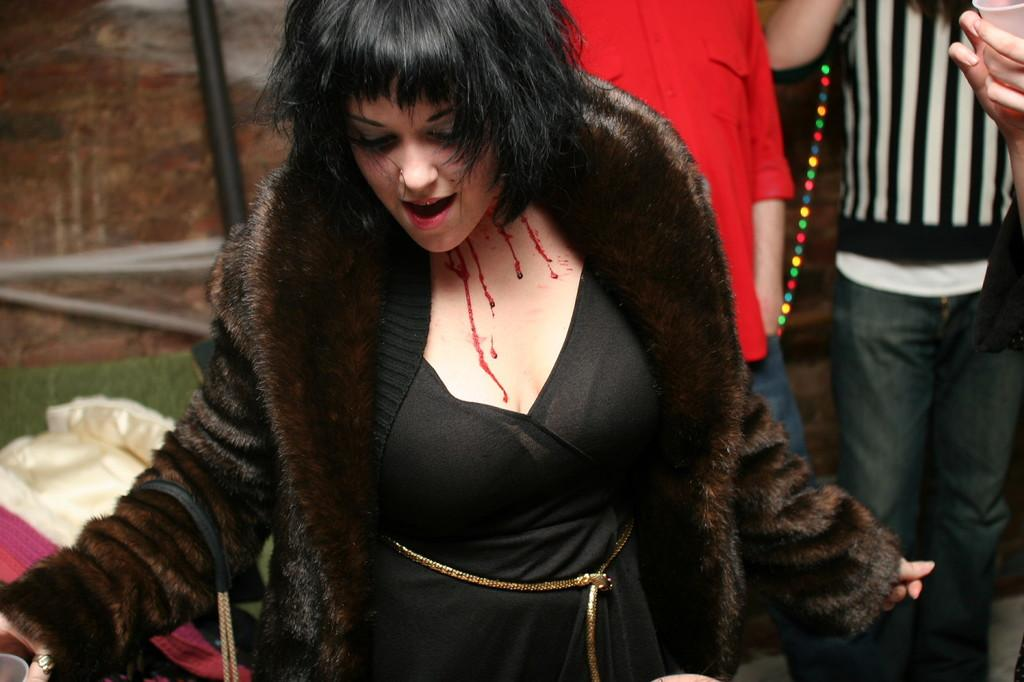Who is the main subject in the image? There is a woman in the image. What is the woman wearing? The woman is wearing a black dress and coat. Can you describe the woman's physical condition? The woman has a bleeding neck. What else can be seen in the background of the image? There are humans standing in the background of the image. How many teeth can be seen in the woman's mouth in the image? There is no information about the woman's teeth in the image, so it cannot be determined. 